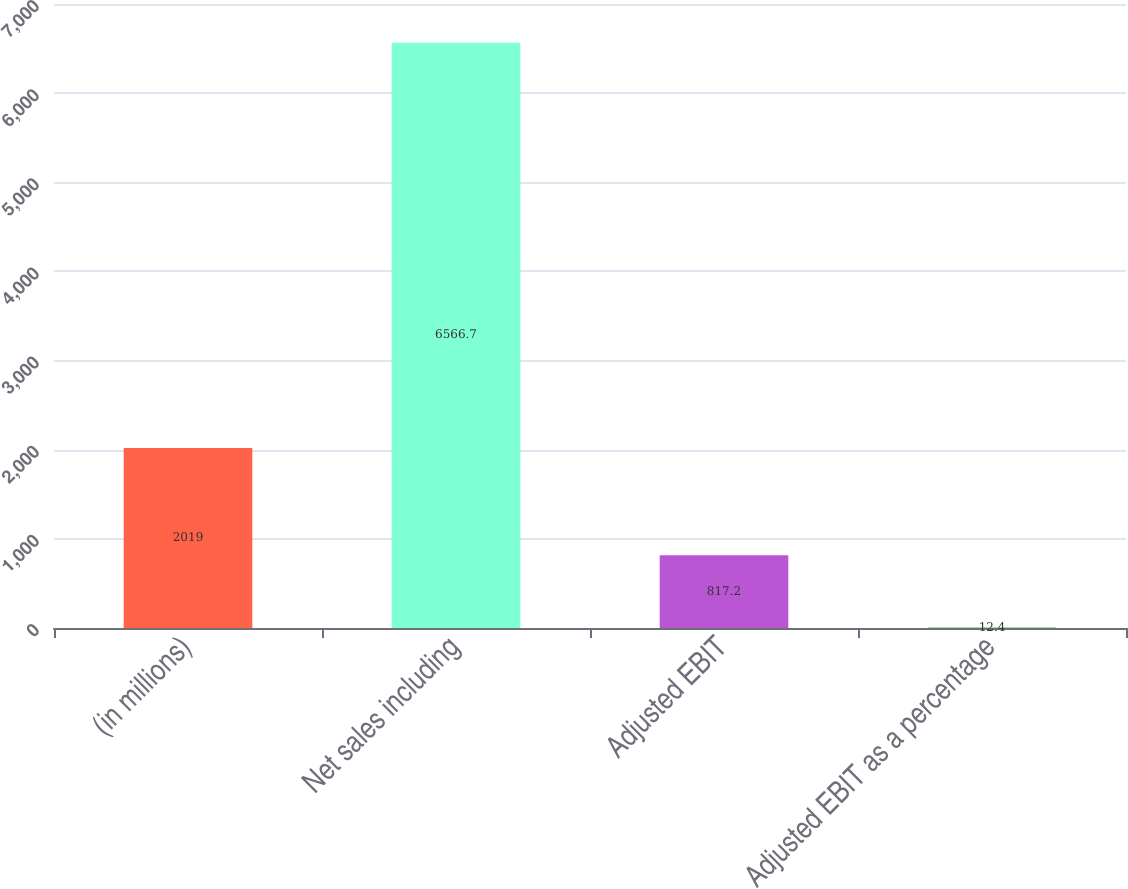Convert chart to OTSL. <chart><loc_0><loc_0><loc_500><loc_500><bar_chart><fcel>(in millions)<fcel>Net sales including<fcel>Adjusted EBIT<fcel>Adjusted EBIT as a percentage<nl><fcel>2019<fcel>6566.7<fcel>817.2<fcel>12.4<nl></chart> 